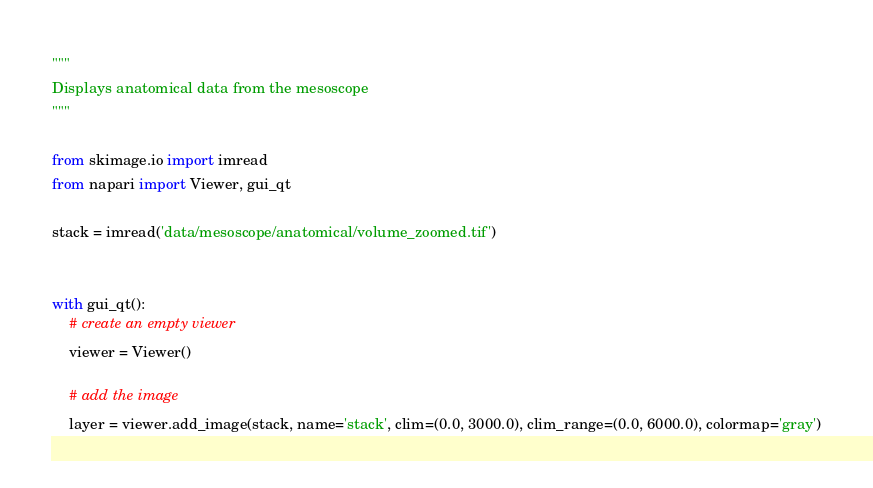<code> <loc_0><loc_0><loc_500><loc_500><_Python_>"""
Displays anatomical data from the mesoscope
"""

from skimage.io import imread
from napari import Viewer, gui_qt

stack = imread('data/mesoscope/anatomical/volume_zoomed.tif')


with gui_qt():
    # create an empty viewer
    viewer = Viewer()

    # add the image
    layer = viewer.add_image(stack, name='stack', clim=(0.0, 3000.0), clim_range=(0.0, 6000.0), colormap='gray')
</code> 